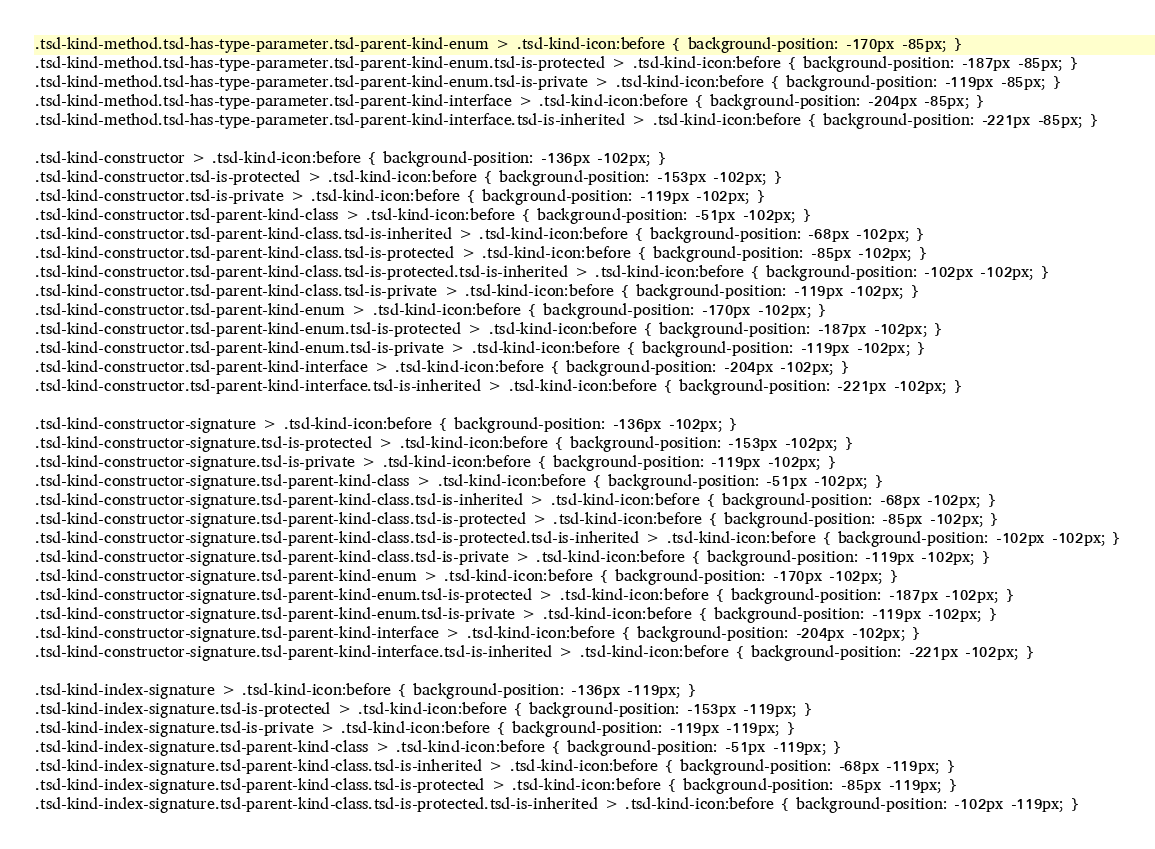<code> <loc_0><loc_0><loc_500><loc_500><_HTML_>.tsd-kind-method.tsd-has-type-parameter.tsd-parent-kind-enum > .tsd-kind-icon:before { background-position: -170px -85px; }
.tsd-kind-method.tsd-has-type-parameter.tsd-parent-kind-enum.tsd-is-protected > .tsd-kind-icon:before { background-position: -187px -85px; }
.tsd-kind-method.tsd-has-type-parameter.tsd-parent-kind-enum.tsd-is-private > .tsd-kind-icon:before { background-position: -119px -85px; }
.tsd-kind-method.tsd-has-type-parameter.tsd-parent-kind-interface > .tsd-kind-icon:before { background-position: -204px -85px; }
.tsd-kind-method.tsd-has-type-parameter.tsd-parent-kind-interface.tsd-is-inherited > .tsd-kind-icon:before { background-position: -221px -85px; }

.tsd-kind-constructor > .tsd-kind-icon:before { background-position: -136px -102px; }
.tsd-kind-constructor.tsd-is-protected > .tsd-kind-icon:before { background-position: -153px -102px; }
.tsd-kind-constructor.tsd-is-private > .tsd-kind-icon:before { background-position: -119px -102px; }
.tsd-kind-constructor.tsd-parent-kind-class > .tsd-kind-icon:before { background-position: -51px -102px; }
.tsd-kind-constructor.tsd-parent-kind-class.tsd-is-inherited > .tsd-kind-icon:before { background-position: -68px -102px; }
.tsd-kind-constructor.tsd-parent-kind-class.tsd-is-protected > .tsd-kind-icon:before { background-position: -85px -102px; }
.tsd-kind-constructor.tsd-parent-kind-class.tsd-is-protected.tsd-is-inherited > .tsd-kind-icon:before { background-position: -102px -102px; }
.tsd-kind-constructor.tsd-parent-kind-class.tsd-is-private > .tsd-kind-icon:before { background-position: -119px -102px; }
.tsd-kind-constructor.tsd-parent-kind-enum > .tsd-kind-icon:before { background-position: -170px -102px; }
.tsd-kind-constructor.tsd-parent-kind-enum.tsd-is-protected > .tsd-kind-icon:before { background-position: -187px -102px; }
.tsd-kind-constructor.tsd-parent-kind-enum.tsd-is-private > .tsd-kind-icon:before { background-position: -119px -102px; }
.tsd-kind-constructor.tsd-parent-kind-interface > .tsd-kind-icon:before { background-position: -204px -102px; }
.tsd-kind-constructor.tsd-parent-kind-interface.tsd-is-inherited > .tsd-kind-icon:before { background-position: -221px -102px; }

.tsd-kind-constructor-signature > .tsd-kind-icon:before { background-position: -136px -102px; }
.tsd-kind-constructor-signature.tsd-is-protected > .tsd-kind-icon:before { background-position: -153px -102px; }
.tsd-kind-constructor-signature.tsd-is-private > .tsd-kind-icon:before { background-position: -119px -102px; }
.tsd-kind-constructor-signature.tsd-parent-kind-class > .tsd-kind-icon:before { background-position: -51px -102px; }
.tsd-kind-constructor-signature.tsd-parent-kind-class.tsd-is-inherited > .tsd-kind-icon:before { background-position: -68px -102px; }
.tsd-kind-constructor-signature.tsd-parent-kind-class.tsd-is-protected > .tsd-kind-icon:before { background-position: -85px -102px; }
.tsd-kind-constructor-signature.tsd-parent-kind-class.tsd-is-protected.tsd-is-inherited > .tsd-kind-icon:before { background-position: -102px -102px; }
.tsd-kind-constructor-signature.tsd-parent-kind-class.tsd-is-private > .tsd-kind-icon:before { background-position: -119px -102px; }
.tsd-kind-constructor-signature.tsd-parent-kind-enum > .tsd-kind-icon:before { background-position: -170px -102px; }
.tsd-kind-constructor-signature.tsd-parent-kind-enum.tsd-is-protected > .tsd-kind-icon:before { background-position: -187px -102px; }
.tsd-kind-constructor-signature.tsd-parent-kind-enum.tsd-is-private > .tsd-kind-icon:before { background-position: -119px -102px; }
.tsd-kind-constructor-signature.tsd-parent-kind-interface > .tsd-kind-icon:before { background-position: -204px -102px; }
.tsd-kind-constructor-signature.tsd-parent-kind-interface.tsd-is-inherited > .tsd-kind-icon:before { background-position: -221px -102px; }

.tsd-kind-index-signature > .tsd-kind-icon:before { background-position: -136px -119px; }
.tsd-kind-index-signature.tsd-is-protected > .tsd-kind-icon:before { background-position: -153px -119px; }
.tsd-kind-index-signature.tsd-is-private > .tsd-kind-icon:before { background-position: -119px -119px; }
.tsd-kind-index-signature.tsd-parent-kind-class > .tsd-kind-icon:before { background-position: -51px -119px; }
.tsd-kind-index-signature.tsd-parent-kind-class.tsd-is-inherited > .tsd-kind-icon:before { background-position: -68px -119px; }
.tsd-kind-index-signature.tsd-parent-kind-class.tsd-is-protected > .tsd-kind-icon:before { background-position: -85px -119px; }
.tsd-kind-index-signature.tsd-parent-kind-class.tsd-is-protected.tsd-is-inherited > .tsd-kind-icon:before { background-position: -102px -119px; }</code> 